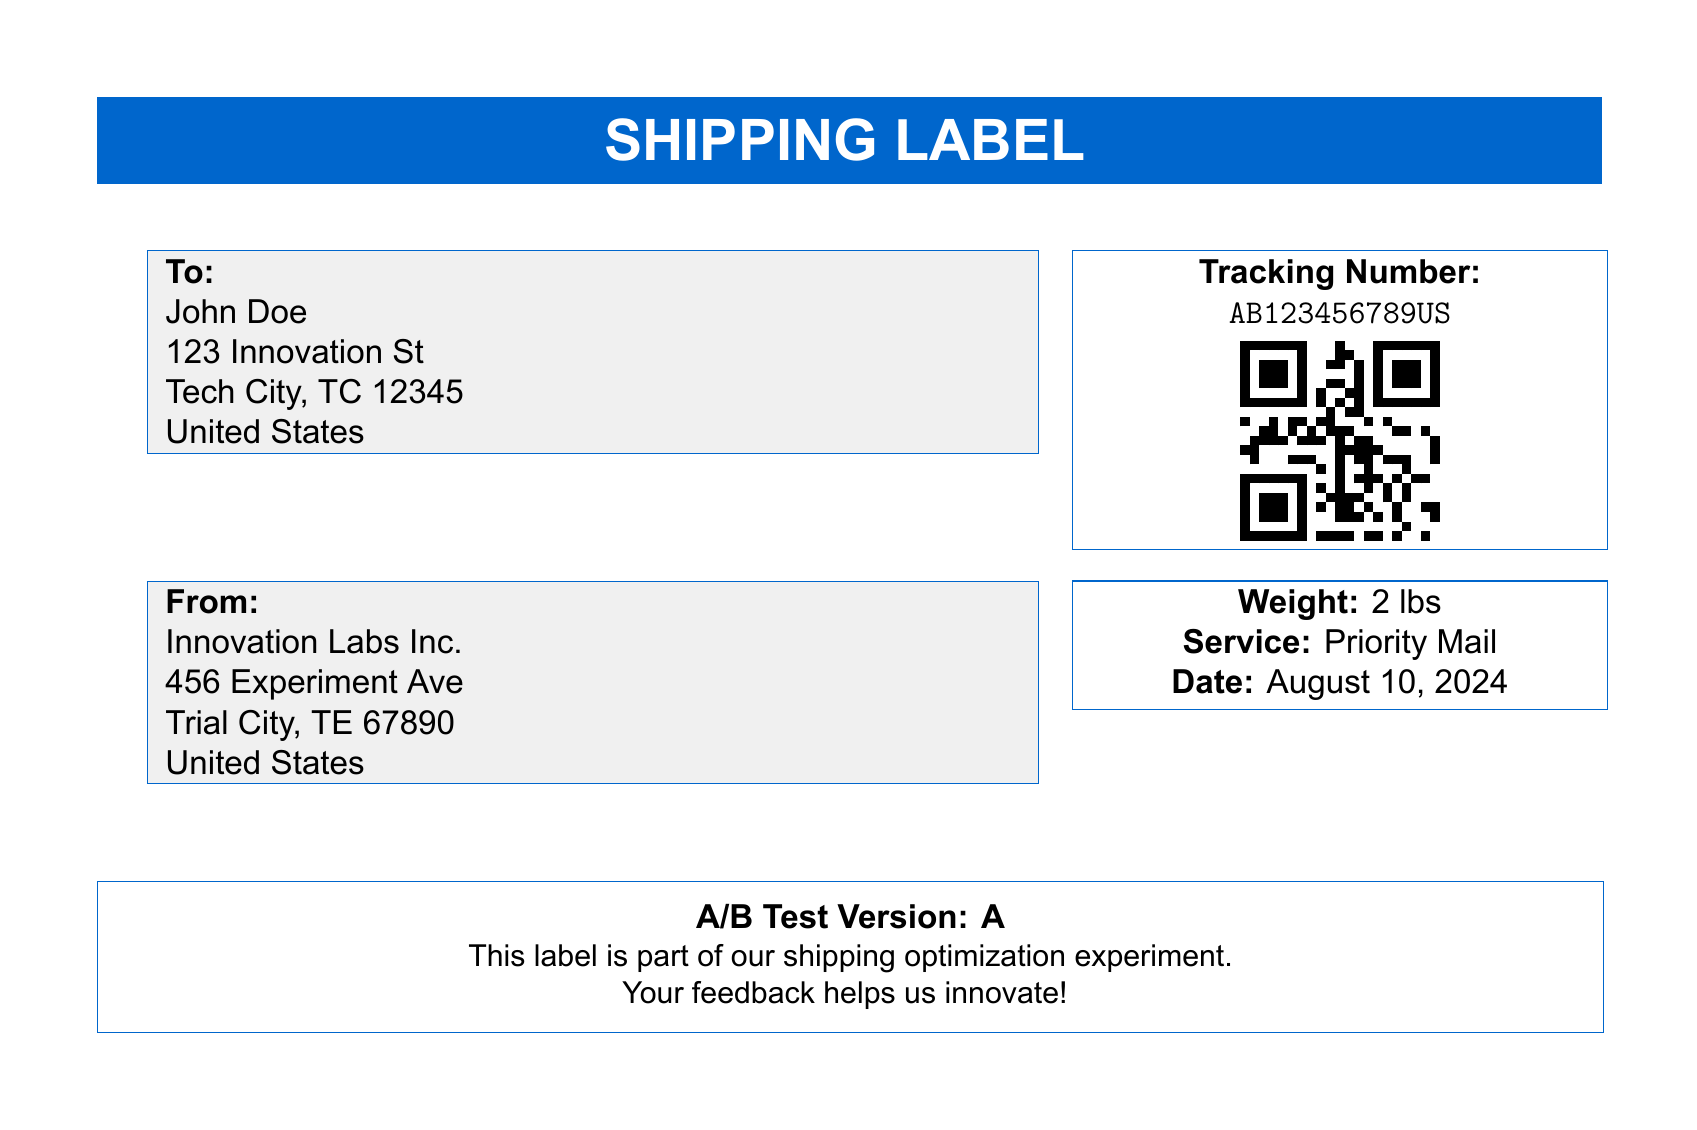What is the recipient's name? The recipient's name is specified in the "To:" section of the document.
Answer: John Doe What is the tracking number? The tracking number is found in the "Tracking Number:" section of the document.
Answer: AB123456789US What is the weight of the package? The weight is mentioned in the "Weight:" section of the document.
Answer: 2 lbs What is the service type for this shipment? The service type is provided under the "Service:" section of the document.
Answer: Priority Mail What is the sender's address? The sender's address can be found in the "From:" section of the document.
Answer: Innovation Labs Inc., 456 Experiment Ave, Trial City, TE 67890, United States How many versions are there in this A/B test? The mention of "A/B Test Version: A" implies the existence of at least two versions.
Answer: Two What is the purpose of this label? The label states that it is part of a shipping optimization experiment, indicating its purpose.
Answer: Shipping optimization experiment What is the date printed on the label? The date is provided under the "Date:" section of the document.
Answer: Today's date What feature encourages feedback from customers? The label includes a note indicating that feedback helps innovate, encouraging customer input.
Answer: Your feedback helps us innovate! 